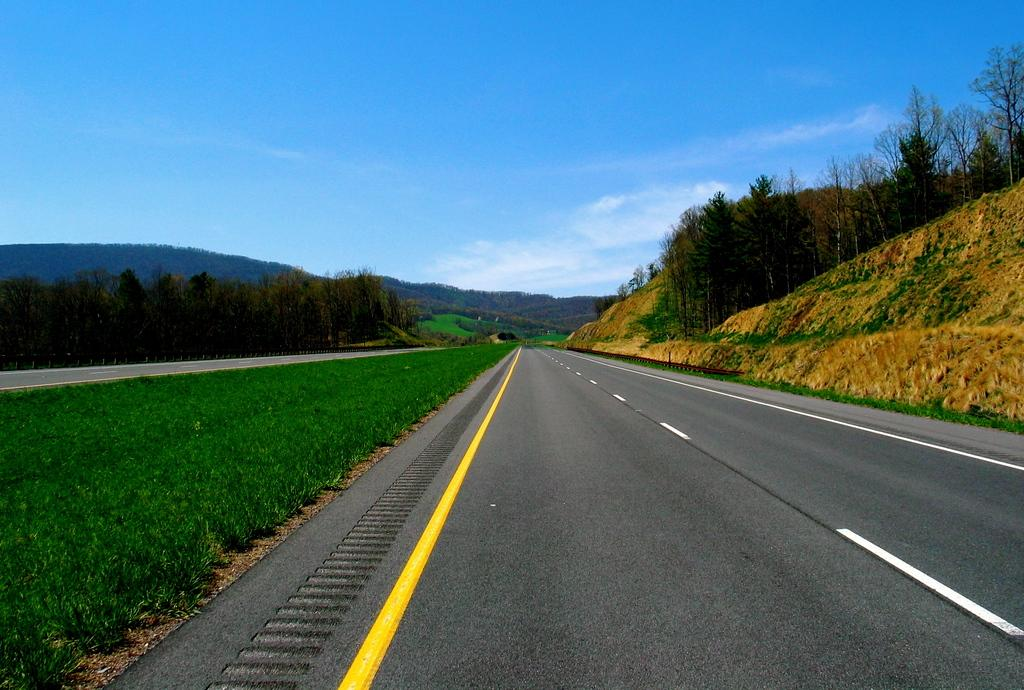What type of vegetation is present in the image? There is grass in the image. What can be seen beside the road in the image? There are trees beside the road in the image. What is visible in the background of the image? Hills and clouds are visible in the background of the image. What type of coil is wrapped around the trees in the image? There is no coil present in the image; the trees are not wrapped in any coil. 